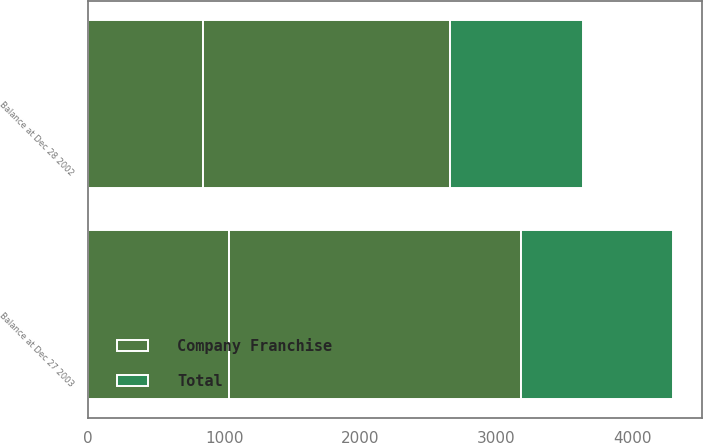Convert chart to OTSL. <chart><loc_0><loc_0><loc_500><loc_500><stacked_bar_chart><ecel><fcel>Balance at Dec 28 2002<fcel>Balance at Dec 27 2003<nl><fcel>nan<fcel>844<fcel>1032<nl><fcel>Total<fcel>973<fcel>1116<nl><fcel>Company Franchise<fcel>1817<fcel>2148<nl></chart> 